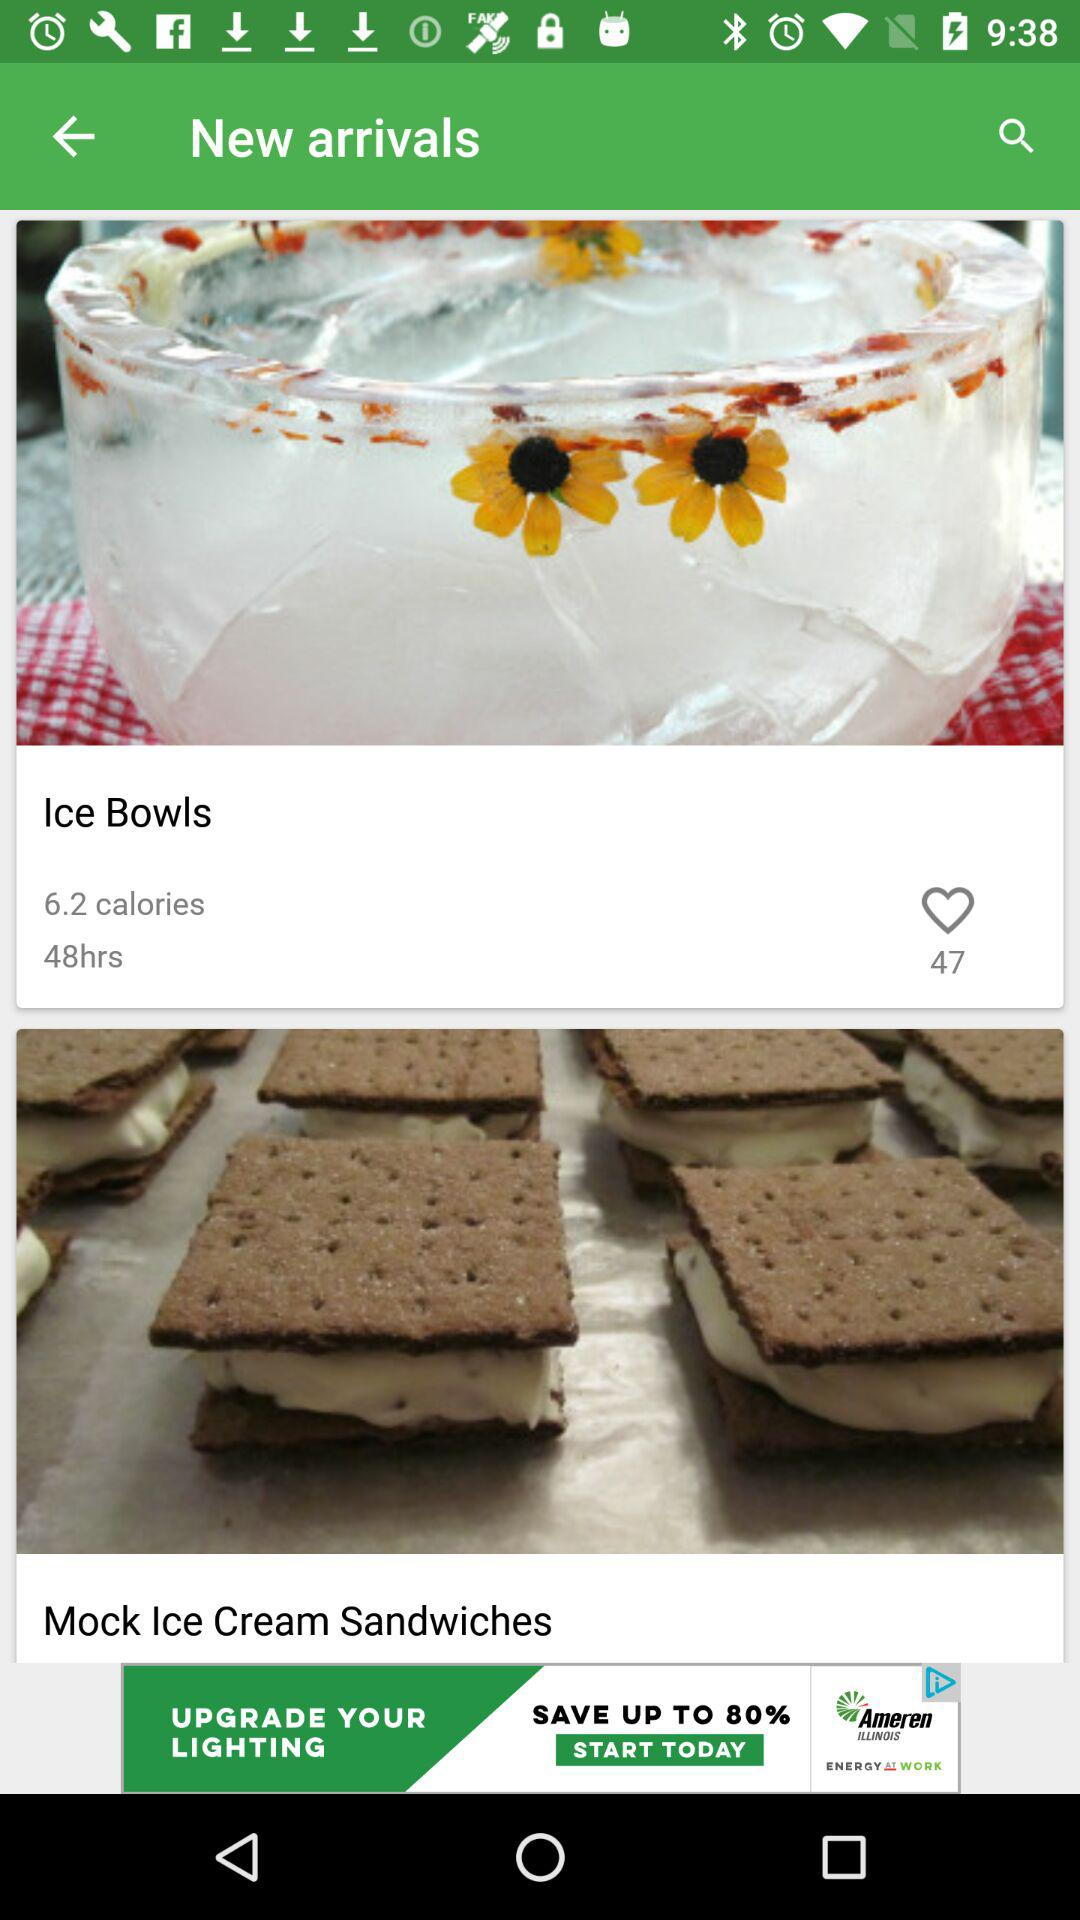How many calories are there in the first item?
Answer the question using a single word or phrase. 6.2 